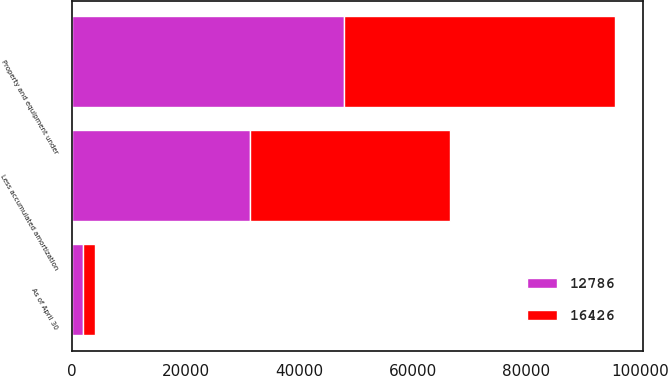Convert chart to OTSL. <chart><loc_0><loc_0><loc_500><loc_500><stacked_bar_chart><ecel><fcel>As of April 30<fcel>Property and equipment under<fcel>Less accumulated amortization<nl><fcel>16426<fcel>2011<fcel>47842<fcel>35056<nl><fcel>12786<fcel>2010<fcel>47844<fcel>31418<nl></chart> 